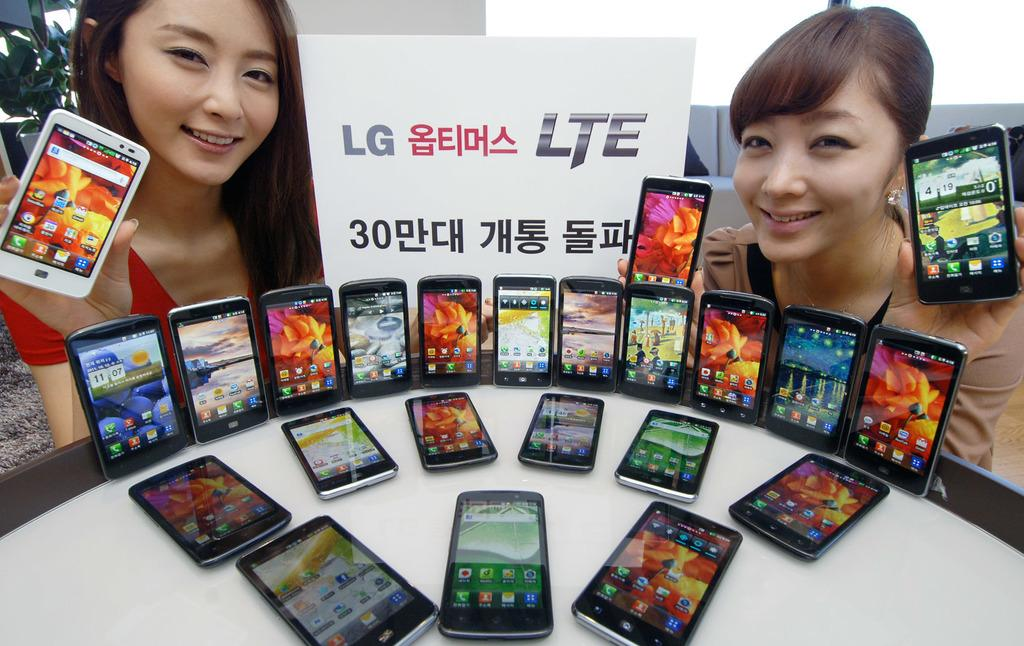<image>
Provide a brief description of the given image. Two women are posing with several Lg branded cell phones on a white table 